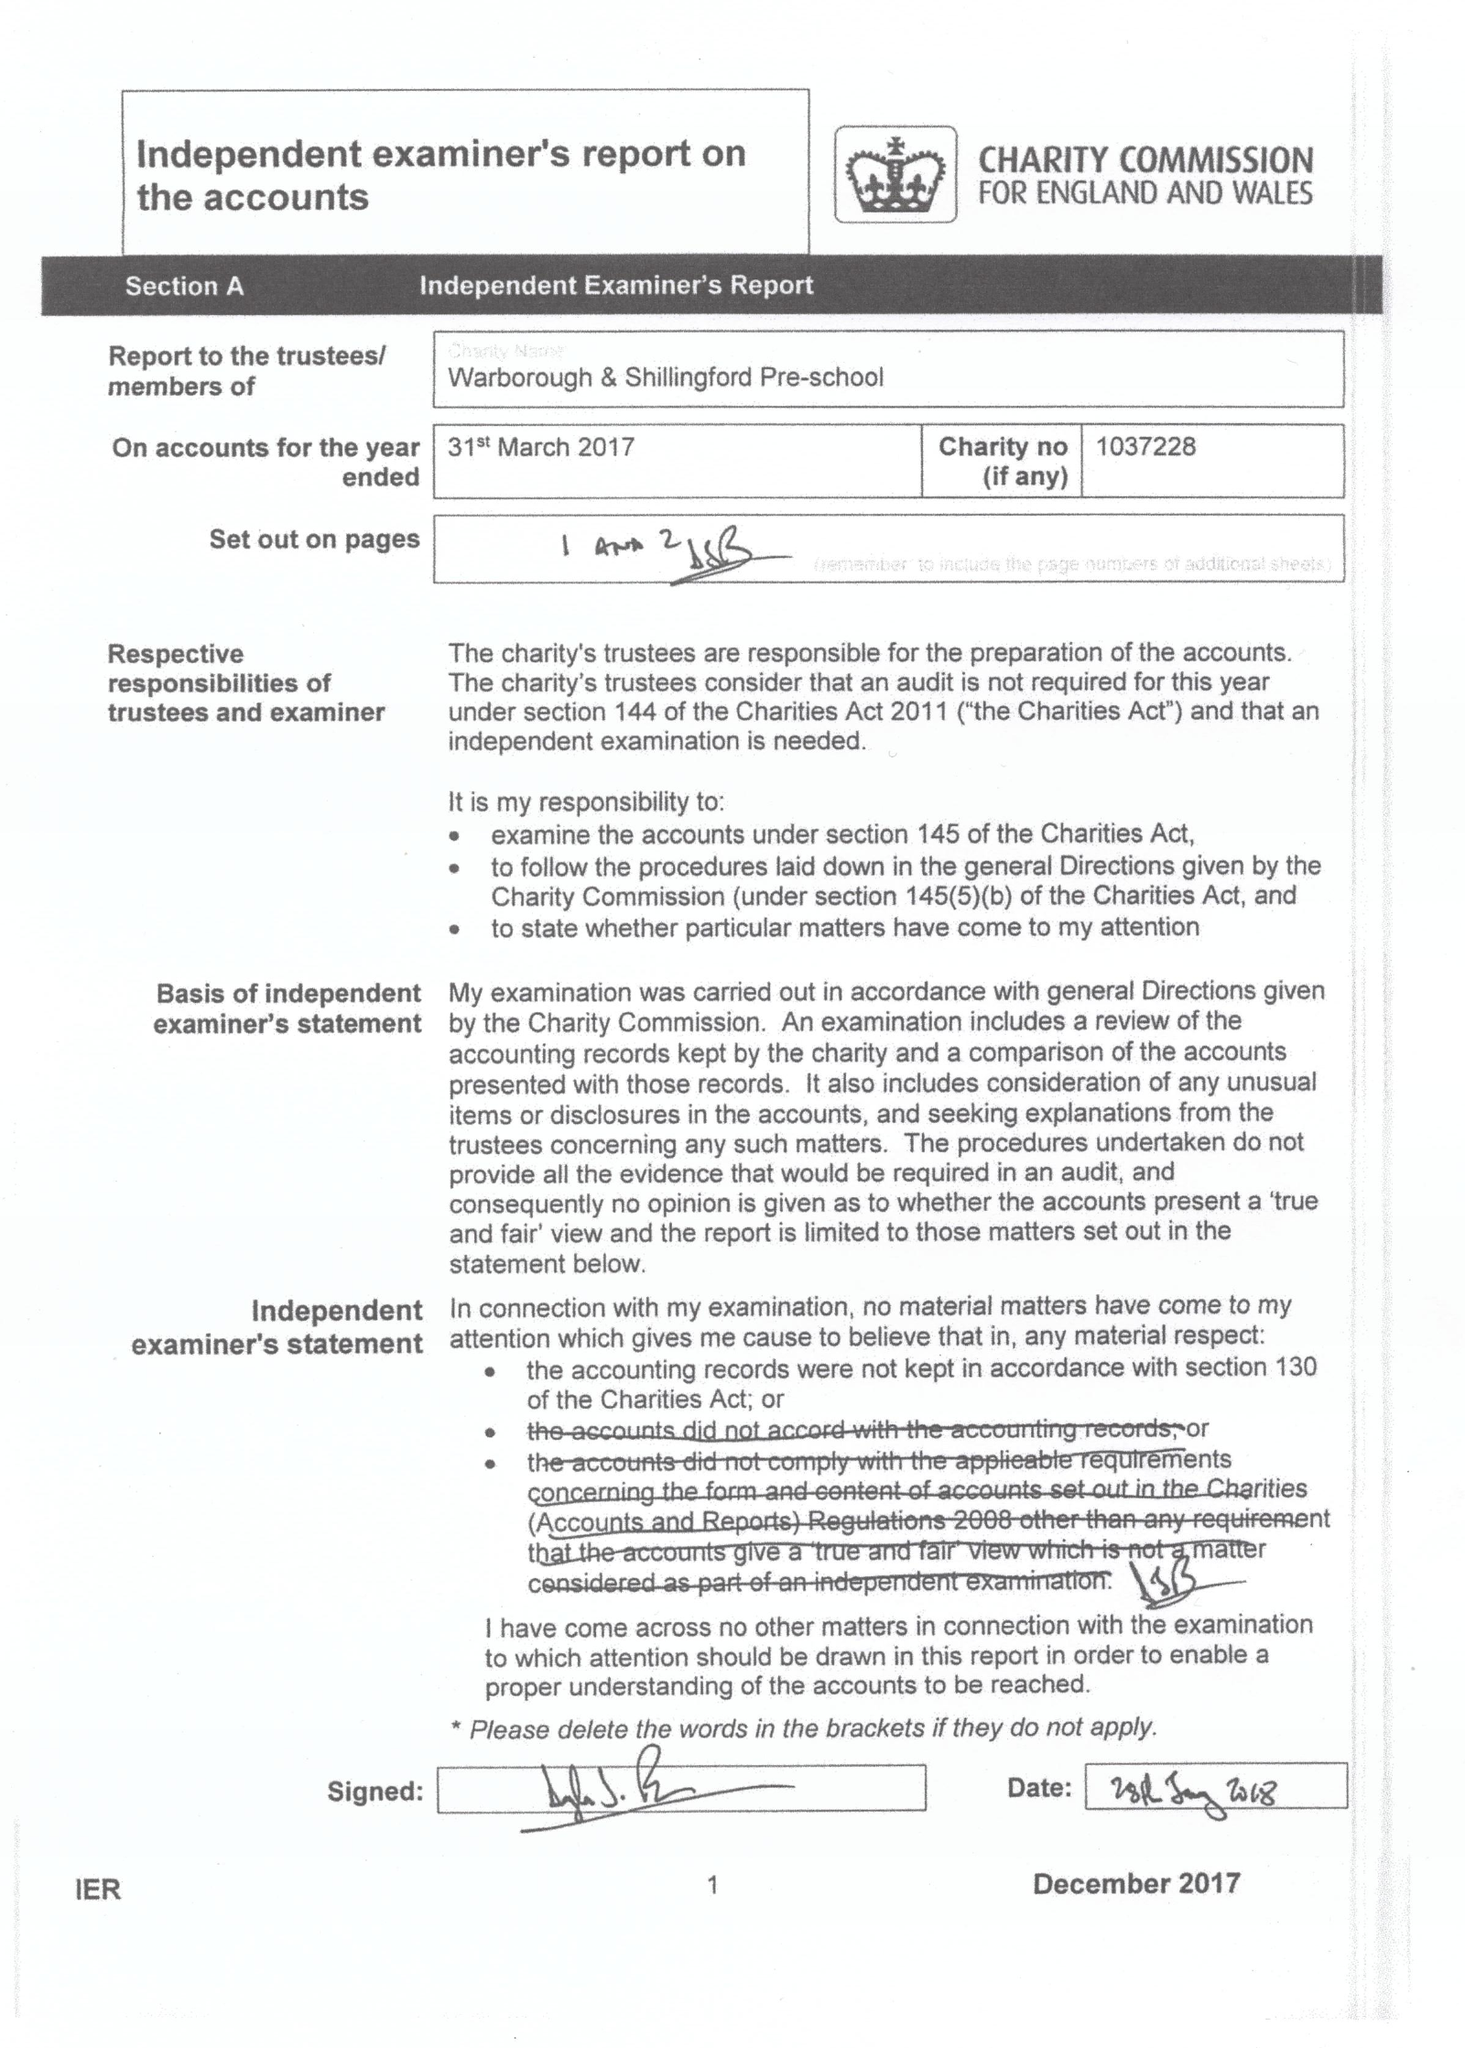What is the value for the charity_name?
Answer the question using a single word or phrase. Warborough Playgroup 